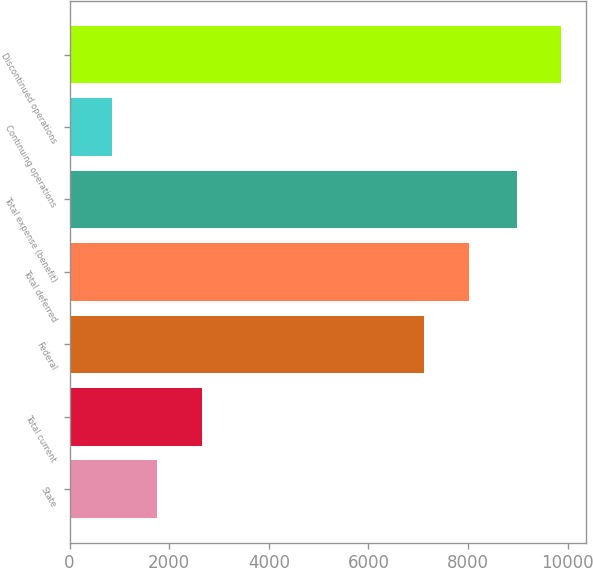Convert chart. <chart><loc_0><loc_0><loc_500><loc_500><bar_chart><fcel>State<fcel>Total current<fcel>Federal<fcel>Total deferred<fcel>Total expense (benefit)<fcel>Continuing operations<fcel>Discontinued operations<nl><fcel>1755.5<fcel>2653<fcel>7116<fcel>8013.5<fcel>8975<fcel>858<fcel>9872.5<nl></chart> 